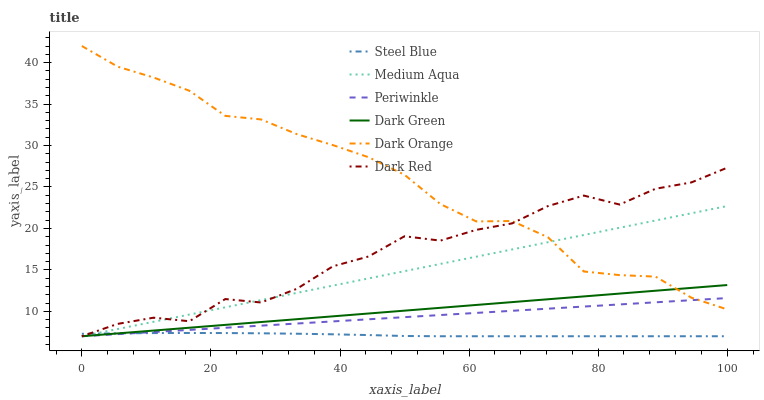Does Steel Blue have the minimum area under the curve?
Answer yes or no. Yes. Does Dark Orange have the maximum area under the curve?
Answer yes or no. Yes. Does Dark Red have the minimum area under the curve?
Answer yes or no. No. Does Dark Red have the maximum area under the curve?
Answer yes or no. No. Is Dark Green the smoothest?
Answer yes or no. Yes. Is Dark Red the roughest?
Answer yes or no. Yes. Is Steel Blue the smoothest?
Answer yes or no. No. Is Steel Blue the roughest?
Answer yes or no. No. Does Dark Red have the lowest value?
Answer yes or no. Yes. Does Dark Orange have the highest value?
Answer yes or no. Yes. Does Dark Red have the highest value?
Answer yes or no. No. Is Steel Blue less than Dark Orange?
Answer yes or no. Yes. Is Dark Orange greater than Steel Blue?
Answer yes or no. Yes. Does Dark Red intersect Steel Blue?
Answer yes or no. Yes. Is Dark Red less than Steel Blue?
Answer yes or no. No. Is Dark Red greater than Steel Blue?
Answer yes or no. No. Does Steel Blue intersect Dark Orange?
Answer yes or no. No. 